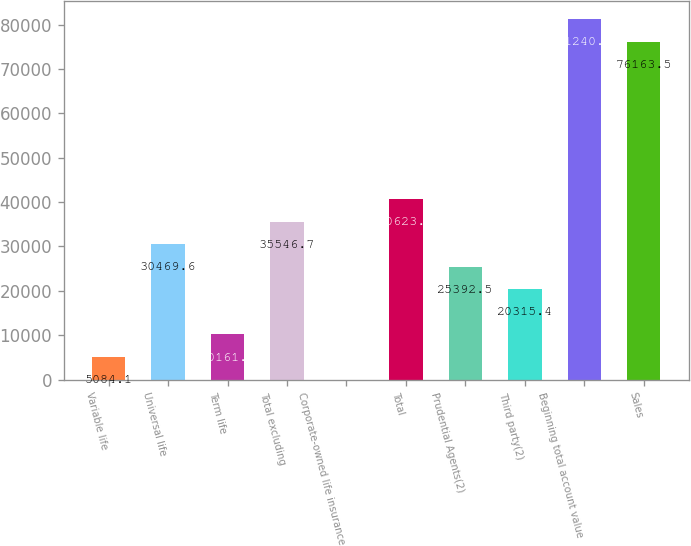Convert chart to OTSL. <chart><loc_0><loc_0><loc_500><loc_500><bar_chart><fcel>Variable life<fcel>Universal life<fcel>Term life<fcel>Total excluding<fcel>Corporate-owned life insurance<fcel>Total<fcel>Prudential Agents(2)<fcel>Third party(2)<fcel>Beginning total account value<fcel>Sales<nl><fcel>5084.1<fcel>30469.6<fcel>10161.2<fcel>35546.7<fcel>7<fcel>40623.8<fcel>25392.5<fcel>20315.4<fcel>81240.6<fcel>76163.5<nl></chart> 